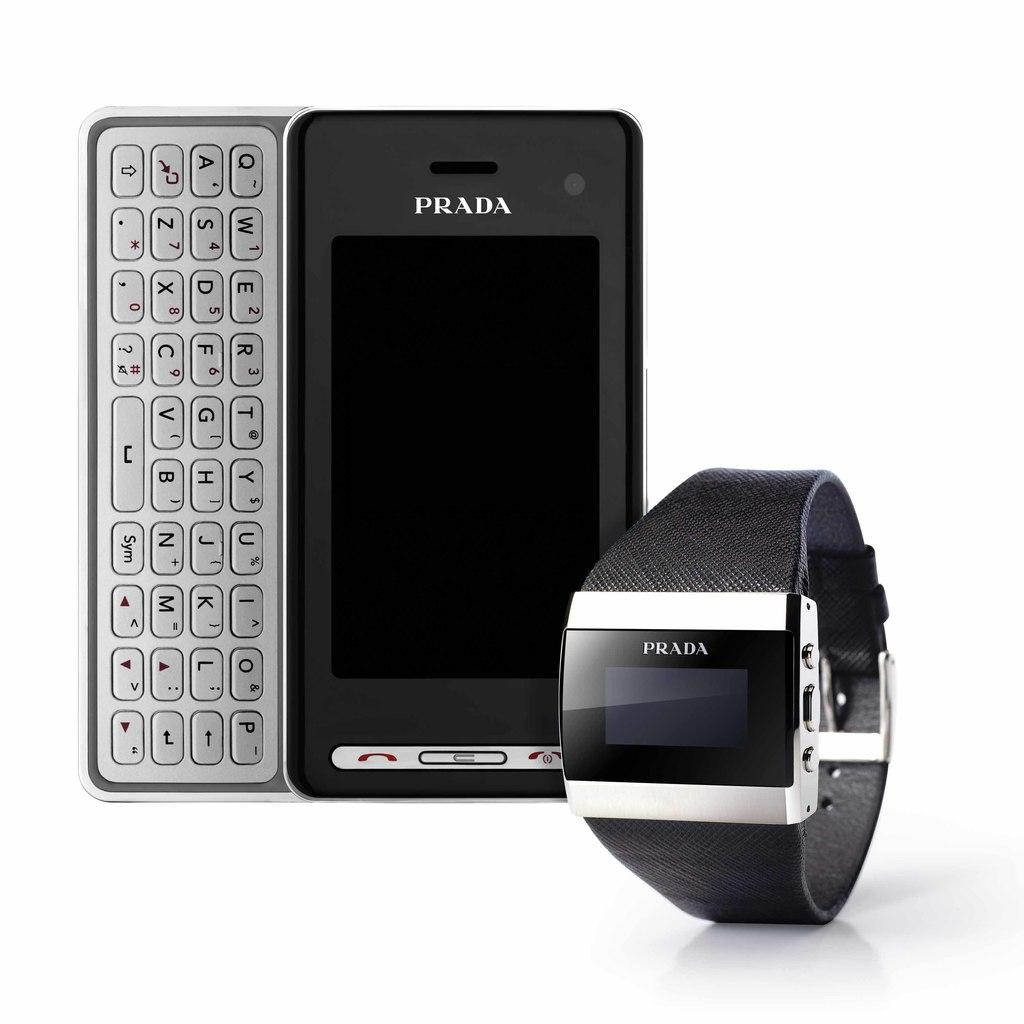Provide a one-sentence caption for the provided image. Prada phone and prada smart watch that is sitting in a picture. 